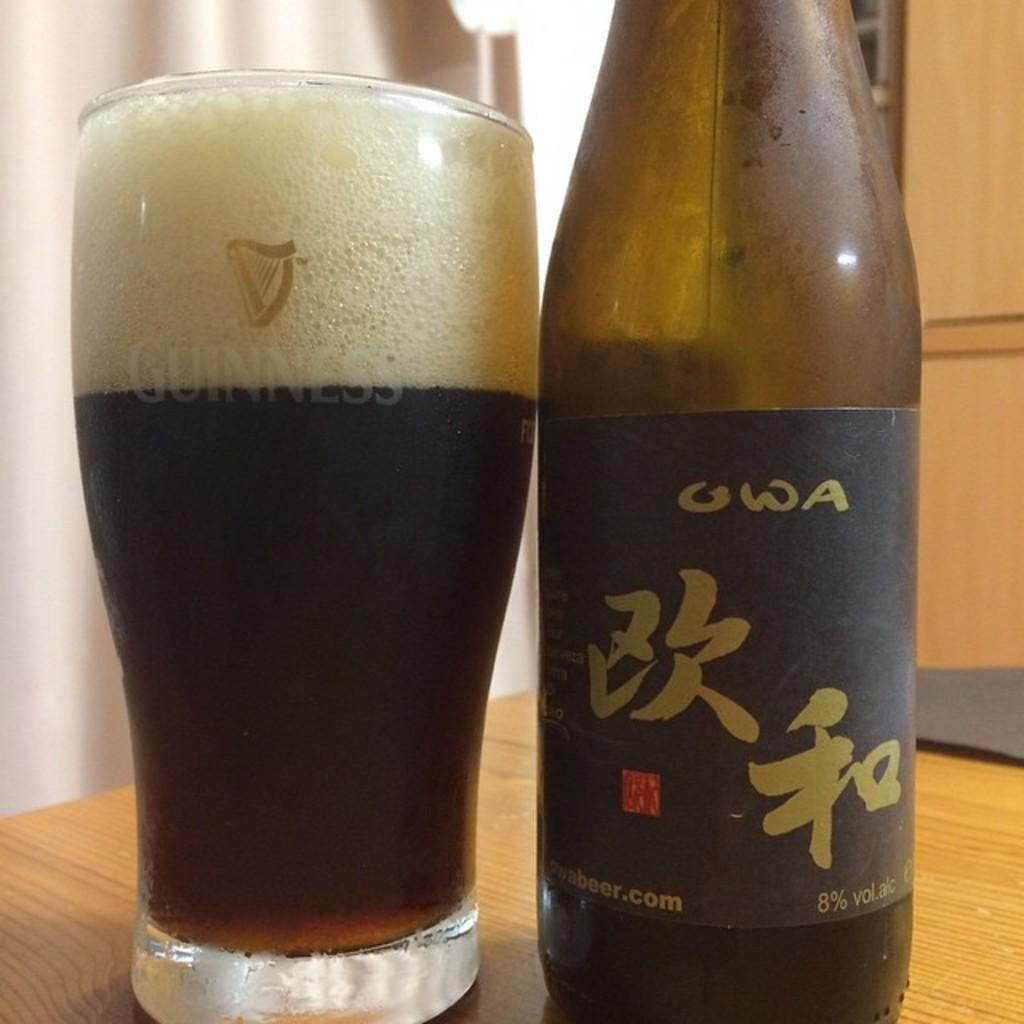What is the name of the drink?
Make the answer very short. Owa. 